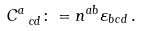<formula> <loc_0><loc_0><loc_500><loc_500>C ^ { a } _ { \ c d } \colon = n ^ { a b } \varepsilon _ { b c d } \, .</formula> 